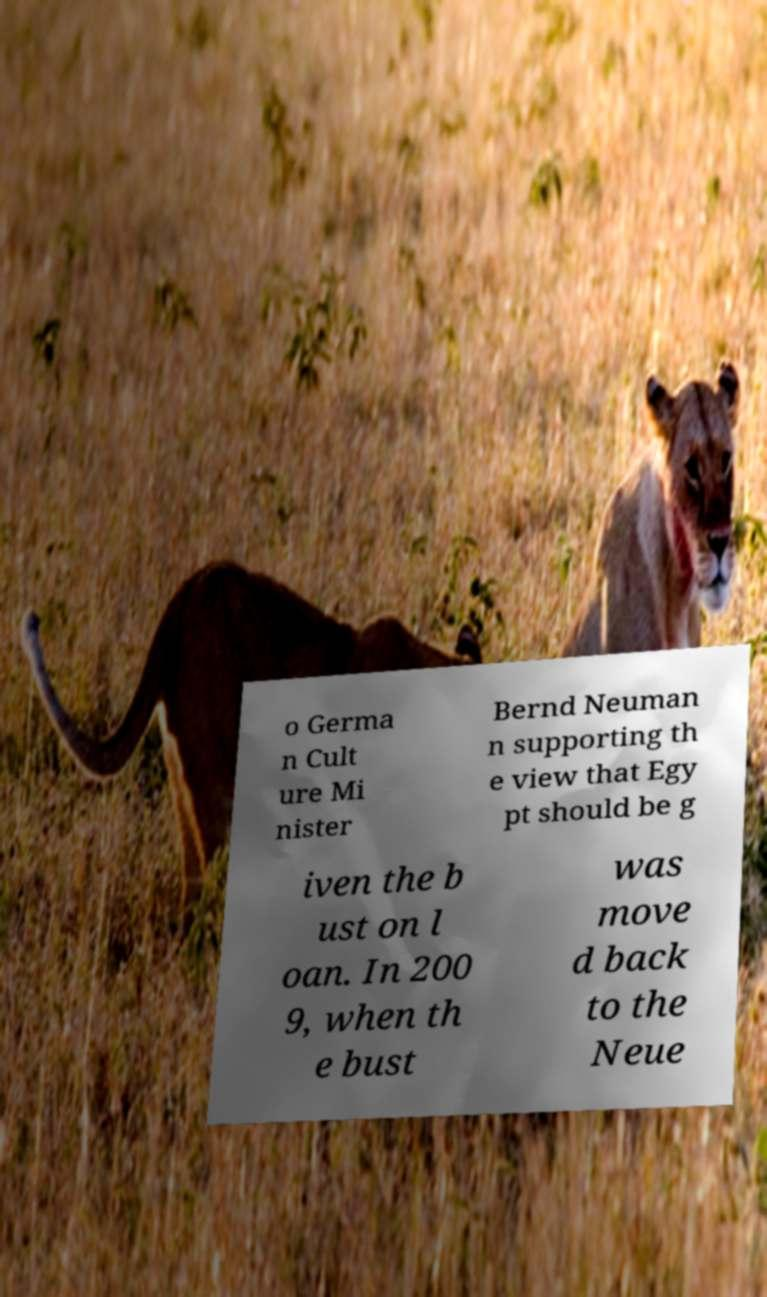Could you extract and type out the text from this image? o Germa n Cult ure Mi nister Bernd Neuman n supporting th e view that Egy pt should be g iven the b ust on l oan. In 200 9, when th e bust was move d back to the Neue 